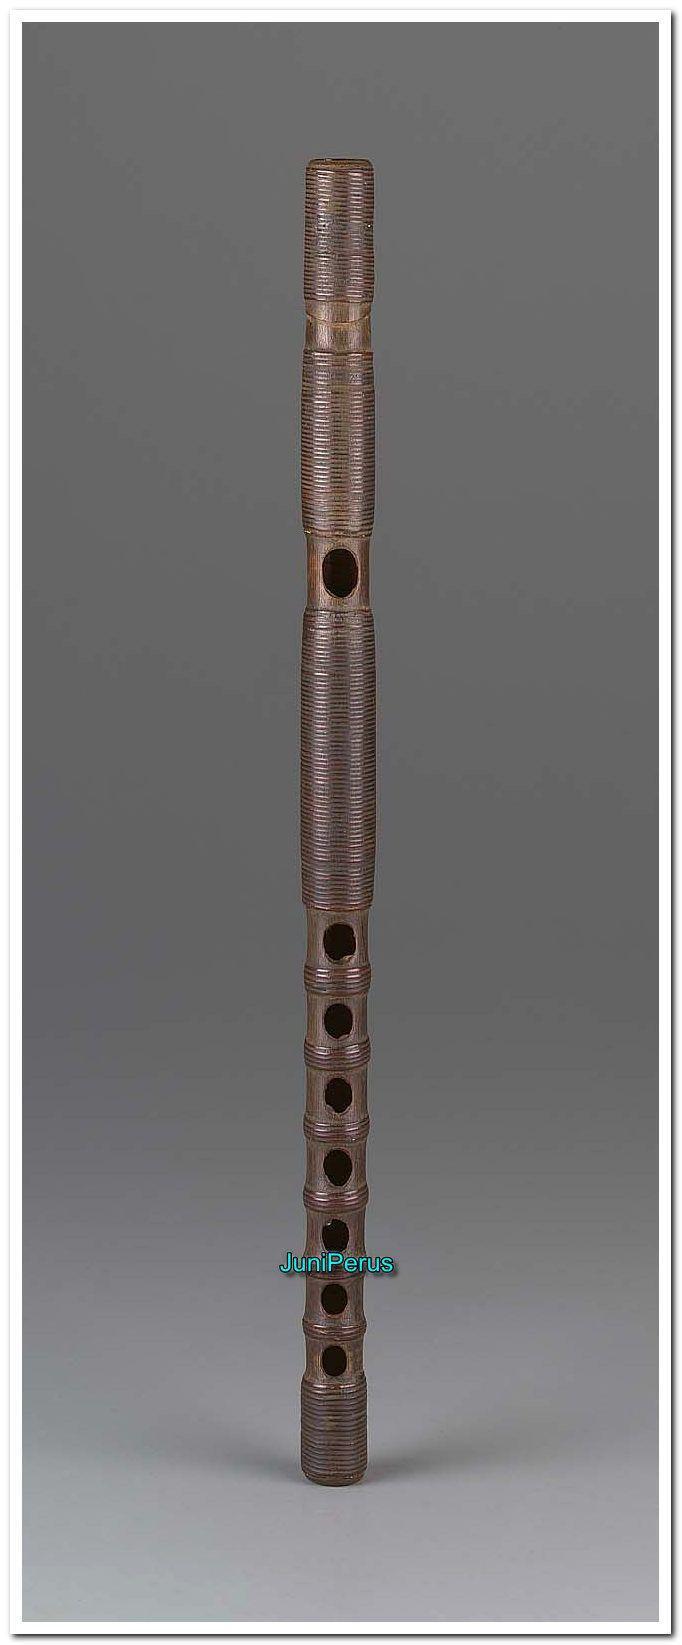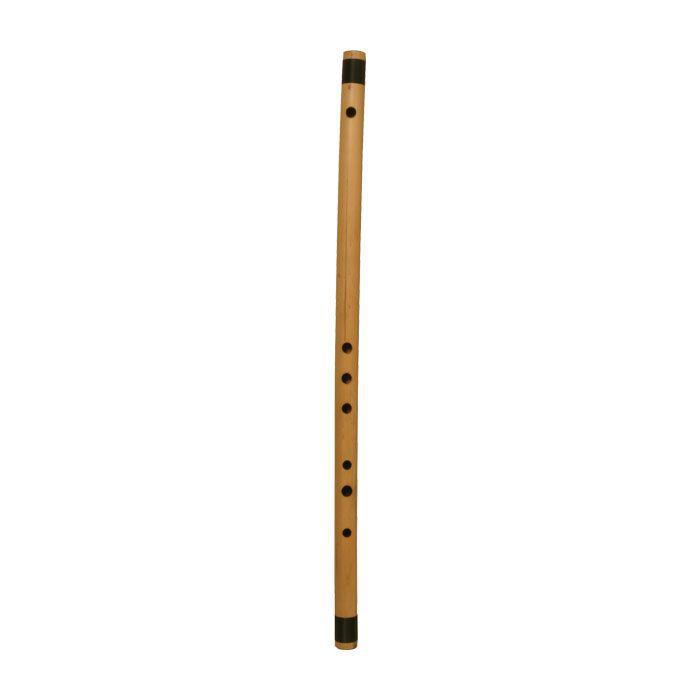The first image is the image on the left, the second image is the image on the right. Given the left and right images, does the statement "There is a single  brown wooden flute standing up with one hole for the month and seven hole at the bottom for the fingers to cover." hold true? Answer yes or no. Yes. 